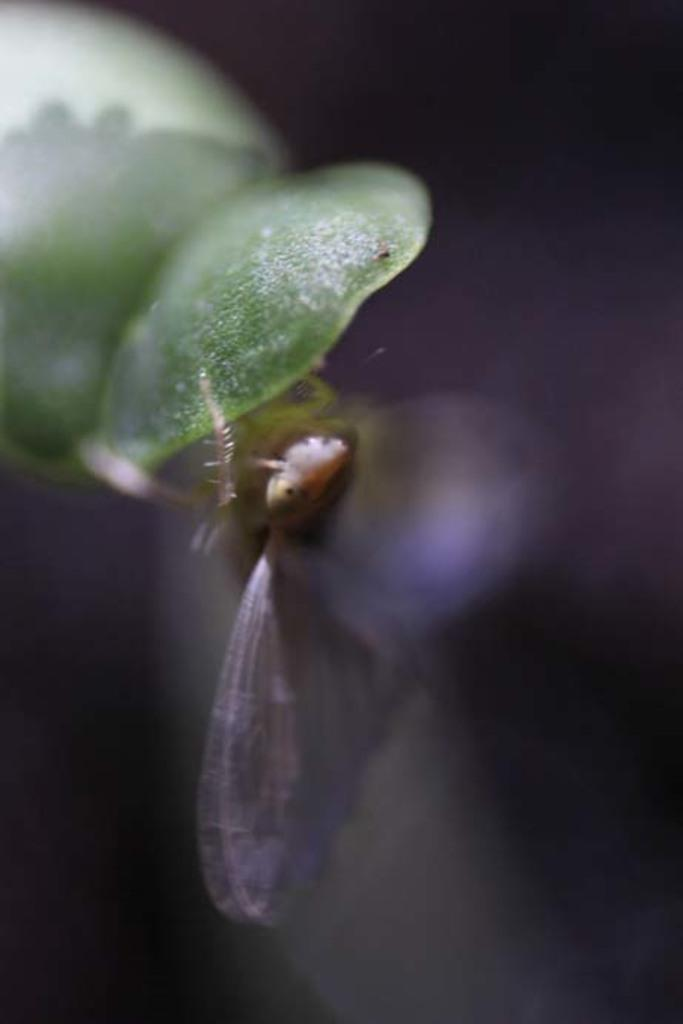What is the overall quality of the image? The image is blurred. What can be seen on the green object in the image? There is an insect on a green object. How would you describe the background of the image? The background of the image is dark. Are there any cobwebs visible in the image? There is no mention of cobwebs in the provided facts, so we cannot determine if any are present in the image. How many pets can be seen in the image? There is no mention of pets in the provided facts, so we cannot determine if any are present in the image. 